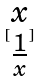<formula> <loc_0><loc_0><loc_500><loc_500>[ \begin{matrix} x \\ \frac { 1 } { x } \end{matrix} ]</formula> 